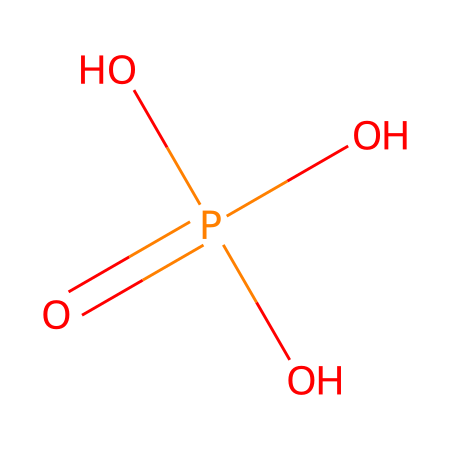What is the name of this chemical? The SMILES representation shows that this chemical contains phosphate groups, specifically having four oxygen atoms bonded to a phosphorus atom. This structure identifies the chemical as phosphoric acid.
Answer: phosphoric acid How many hydrogen atoms are present in this molecule? The structural formula shows three hydroxyl groups (OH) connected to the phosphorus atom, which indicates there are three hydrogen atoms in total.
Answer: three What type of acid is phosphoric acid? Phosphoric acid is considered a mineral acid, as it is derived from inorganic sources mineral phosphate.
Answer: mineral acid How many oxygen atoms are in phosphoric acid? Observing the SMILES representation, there are four oxygen atoms noted in the structure: one double-bonded to phosphorus and three singly bonded.
Answer: four Why is phosphoric acid effective in rust removal? The presence of three acidic protons allows phosphoric acid to react with iron oxides (rust) to convert them into soluble phosphates, which helps in the removal of rust.
Answer: soluble phosphates What is the oxidation state of phosphorus in phosphoric acid? In phosphoric acid, phosphorus typically has an oxidation state of +5, as it is connected to four oxygen atoms, which impact its electron density and charge.
Answer: +5 